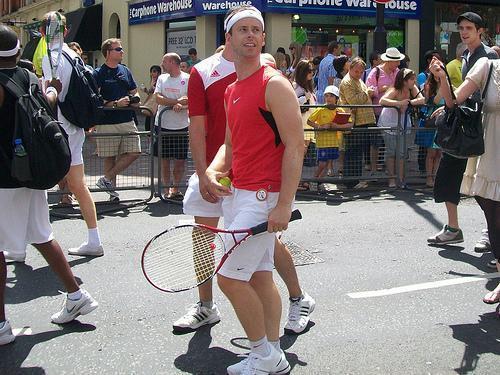How many knapsacks are visible?
Give a very brief answer. 2. 